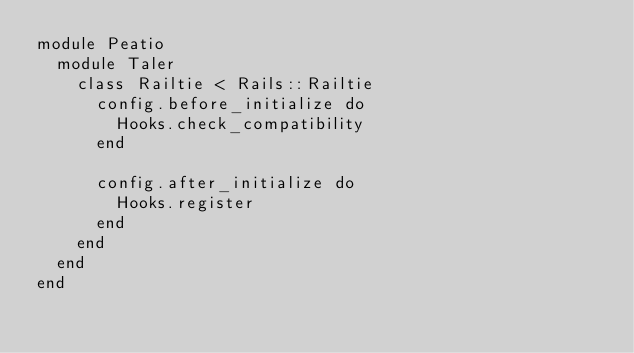Convert code to text. <code><loc_0><loc_0><loc_500><loc_500><_Ruby_>module Peatio
  module Taler
    class Railtie < Rails::Railtie
      config.before_initialize do
        Hooks.check_compatibility
      end

      config.after_initialize do
        Hooks.register
      end
    end
  end
end
</code> 